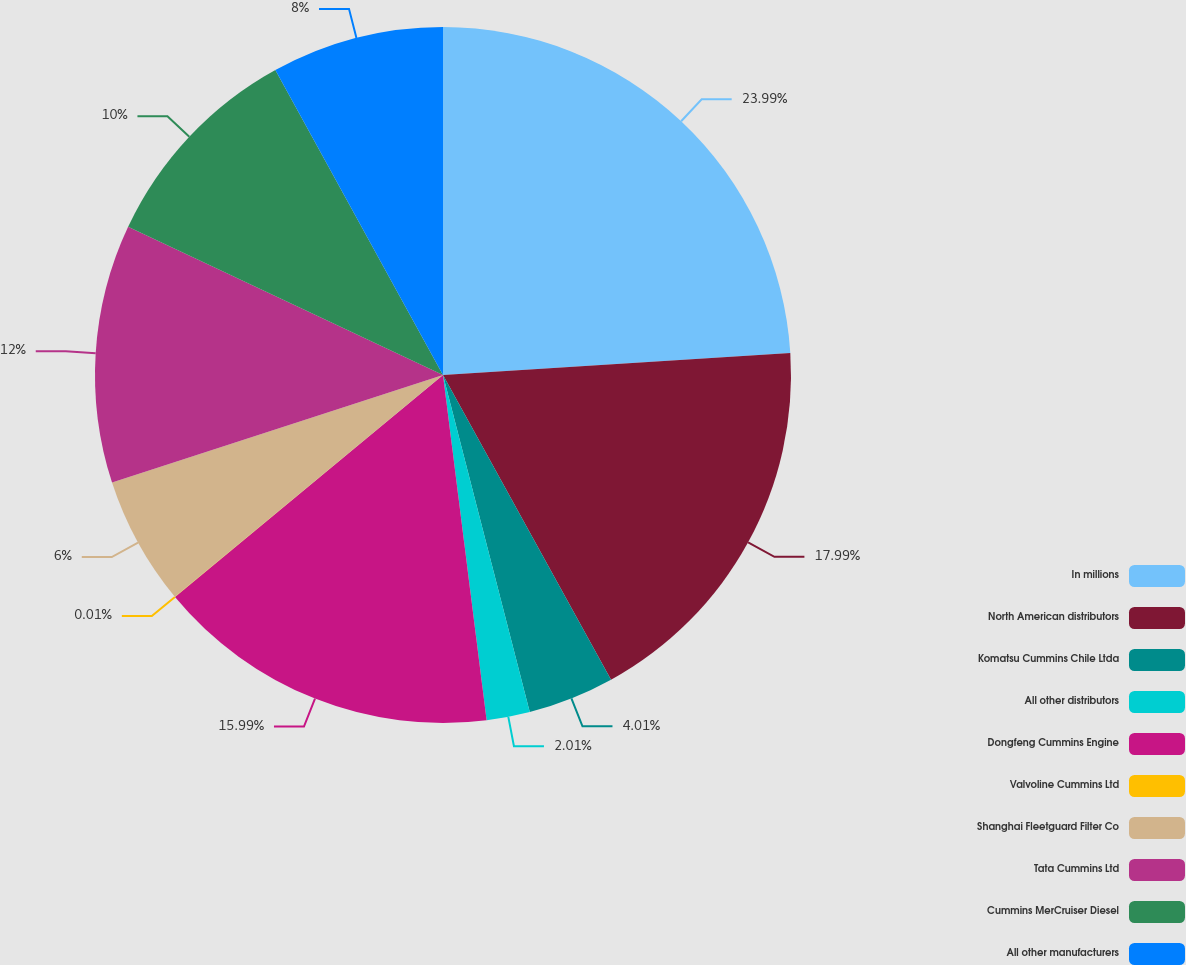<chart> <loc_0><loc_0><loc_500><loc_500><pie_chart><fcel>In millions<fcel>North American distributors<fcel>Komatsu Cummins Chile Ltda<fcel>All other distributors<fcel>Dongfeng Cummins Engine<fcel>Valvoline Cummins Ltd<fcel>Shanghai Fleetguard Filter Co<fcel>Tata Cummins Ltd<fcel>Cummins MerCruiser Diesel<fcel>All other manufacturers<nl><fcel>23.99%<fcel>17.99%<fcel>4.01%<fcel>2.01%<fcel>15.99%<fcel>0.01%<fcel>6.0%<fcel>12.0%<fcel>10.0%<fcel>8.0%<nl></chart> 